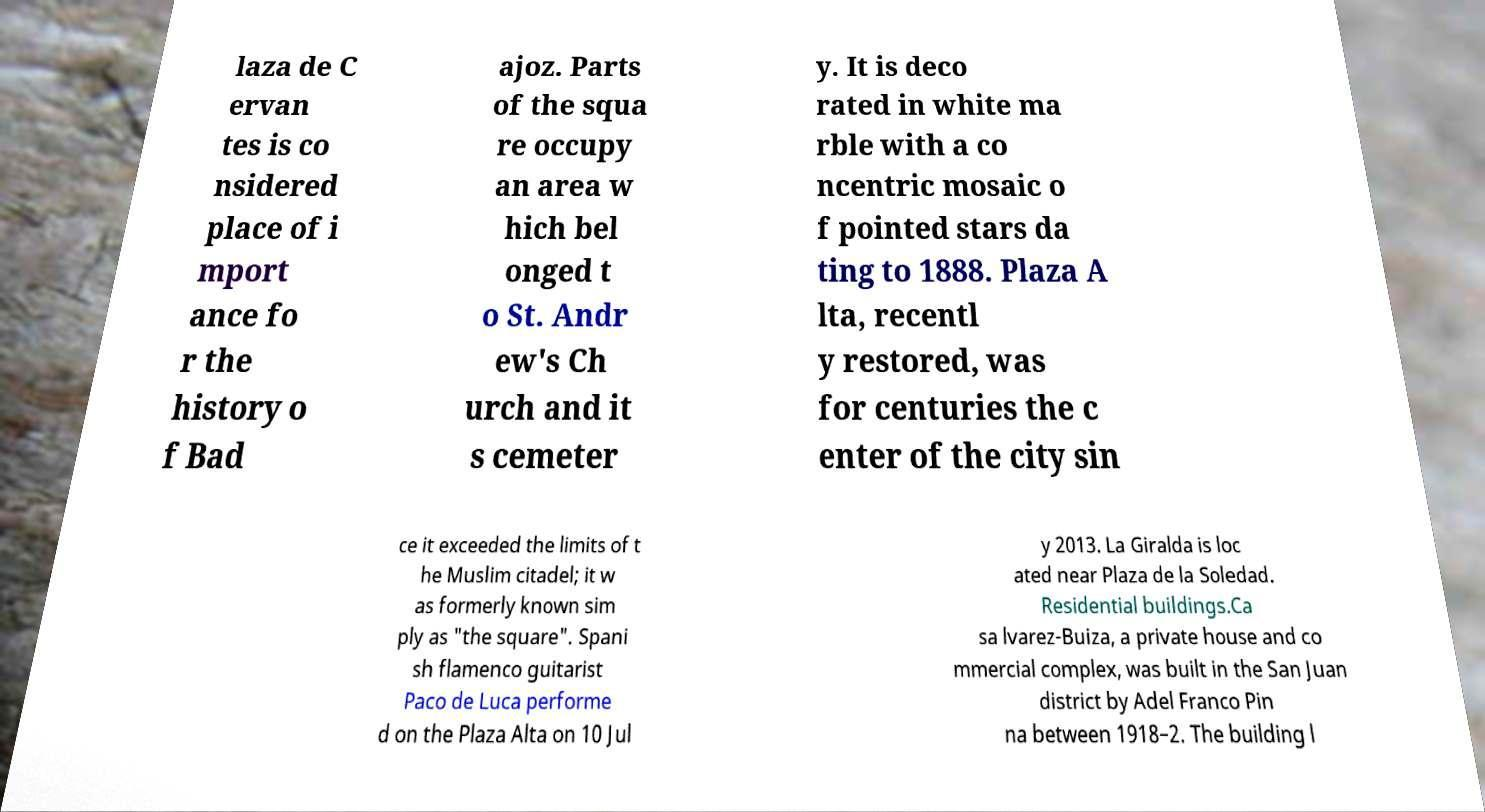I need the written content from this picture converted into text. Can you do that? laza de C ervan tes is co nsidered place of i mport ance fo r the history o f Bad ajoz. Parts of the squa re occupy an area w hich bel onged t o St. Andr ew's Ch urch and it s cemeter y. It is deco rated in white ma rble with a co ncentric mosaic o f pointed stars da ting to 1888. Plaza A lta, recentl y restored, was for centuries the c enter of the city sin ce it exceeded the limits of t he Muslim citadel; it w as formerly known sim ply as "the square". Spani sh flamenco guitarist Paco de Luca performe d on the Plaza Alta on 10 Jul y 2013. La Giralda is loc ated near Plaza de la Soledad. Residential buildings.Ca sa lvarez-Buiza, a private house and co mmercial complex, was built in the San Juan district by Adel Franco Pin na between 1918–2. The building l 